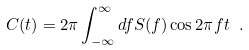Convert formula to latex. <formula><loc_0><loc_0><loc_500><loc_500>C ( t ) = 2 \pi \int _ { - \infty } ^ { \infty } d f S ( f ) \cos 2 \pi f t \ .</formula> 